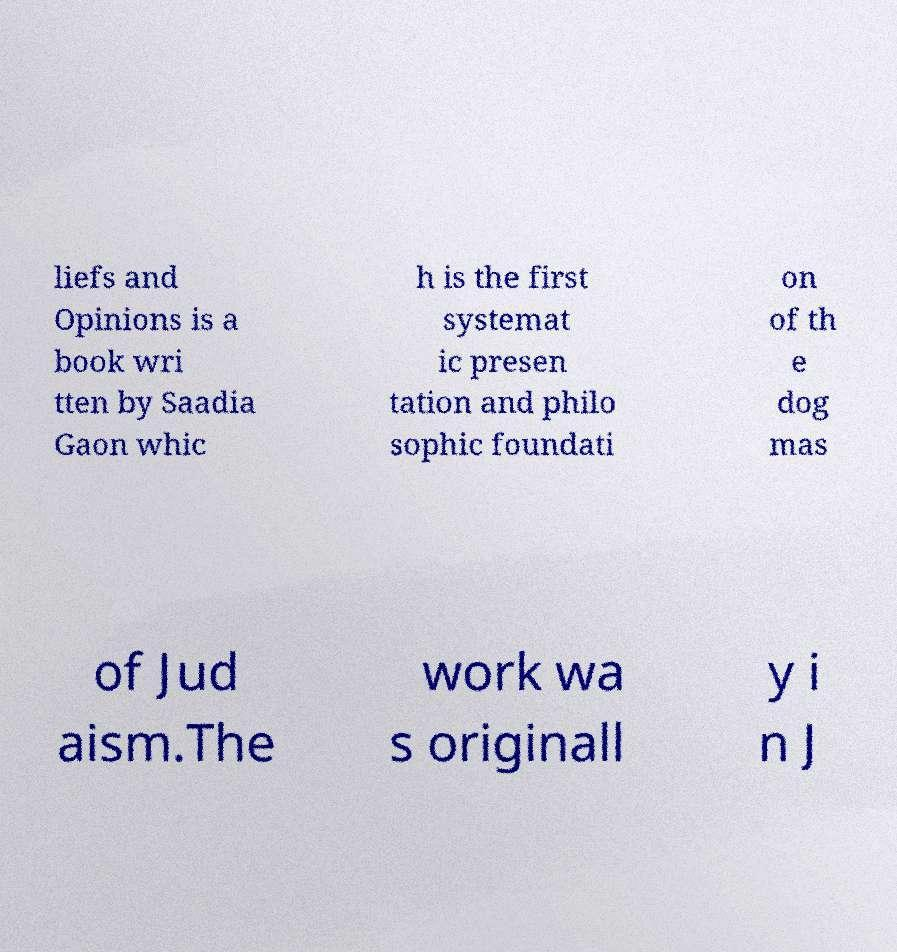Can you read and provide the text displayed in the image?This photo seems to have some interesting text. Can you extract and type it out for me? liefs and Opinions is a book wri tten by Saadia Gaon whic h is the first systemat ic presen tation and philo sophic foundati on of th e dog mas of Jud aism.The work wa s originall y i n J 